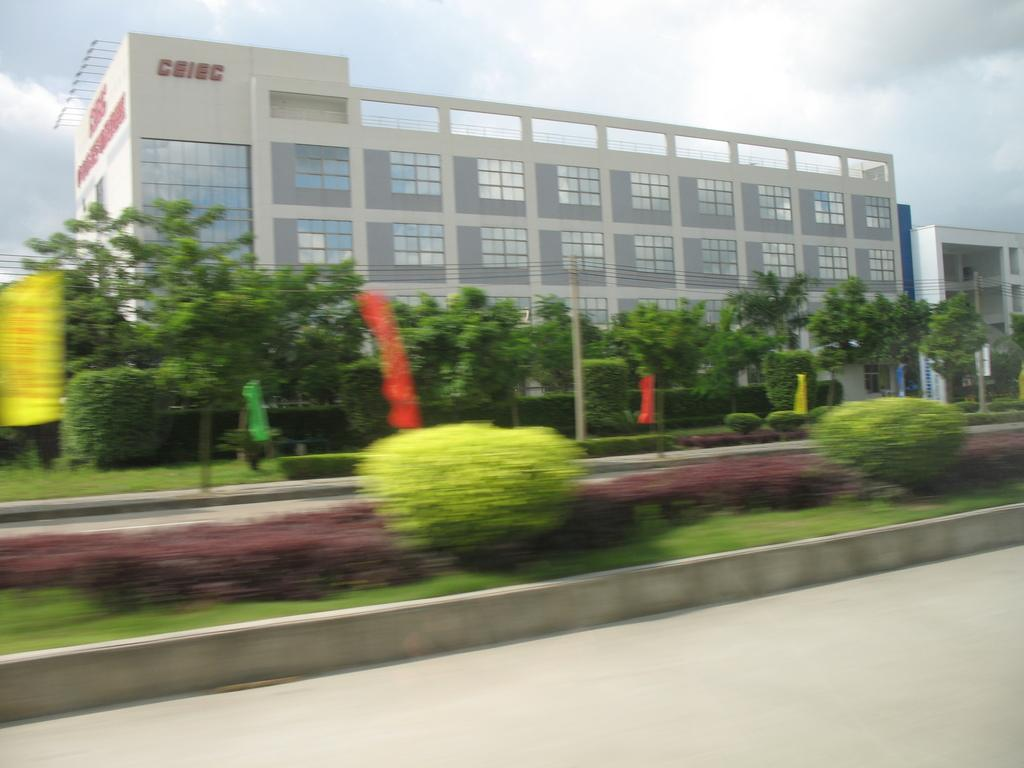What type of vegetation is present in the image? There are trees in the image. What color are the trees? The trees are green. What other objects can be seen in the image besides the trees? There are colorful flags and a building in the image. What color is the building? The building is white. What can be seen in the background of the image? The sky is visible in the background of the image, and it has both white and blue colors. What type of button can be seen on the frame of the image? There is no frame or button present in the image. How does the guide help navigate through the image? There is no guide present in the image, so it cannot help navigate through it. 